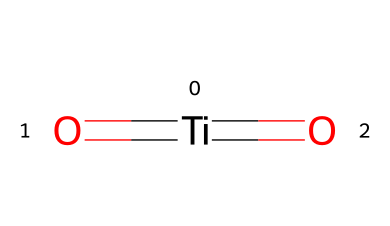What is the central atom in this structure? The SMILES representation shows [Ti], indicating titanium is the central atom surrounded by oxygen.
Answer: titanium How many oxygen atoms are present? The SMILES notation shows two =O groups, indicating there are two oxygen atoms in the structure.
Answer: two What is the oxidation state of titanium in this compound? Each oxygen atom forms a double bond with titanium, suggesting an oxidation state of +4 for titanium in this structure.
Answer: +4 What type of chemical is titanium dioxide classified as? Titanium dioxide is known as an inorganic pigment used in sunscreens, classified as an inorganic compound.
Answer: inorganic compound What role does titanium dioxide serve in cosmetics? Titanium dioxide acts as a physical sunscreen agent, reflecting and scattering UV radiation, thereby protecting the skin from sun damage.
Answer: sunscreen agent How does the structure contribute to its UV protection properties? The presence of titanium surrounded by oxygen means it can efficiently absorb and scatter UV light, enhancing its protective effects in cosmetic applications.
Answer: efficient UV absorber Is titanium dioxide soluble in water? Titanium dioxide is generally insoluble in water, which is typical for many inorganic compounds used in cosmetic formulations.
Answer: insoluble 